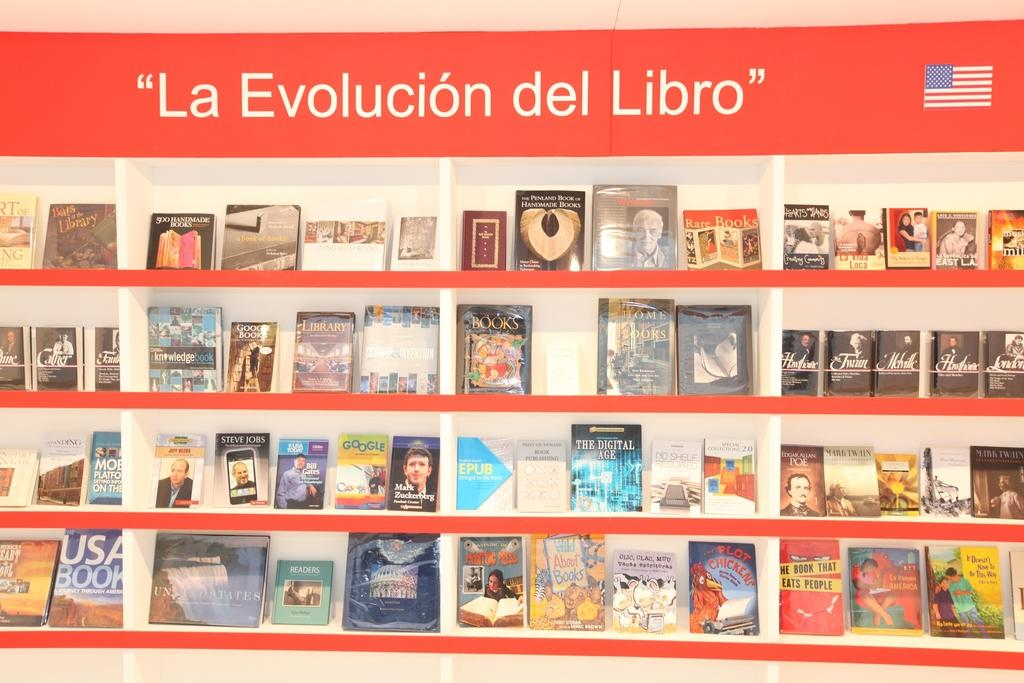<image>
Create a compact narrative representing the image presented. Library showing a group of books and the titled "La Evolucion del Libro" on top. 